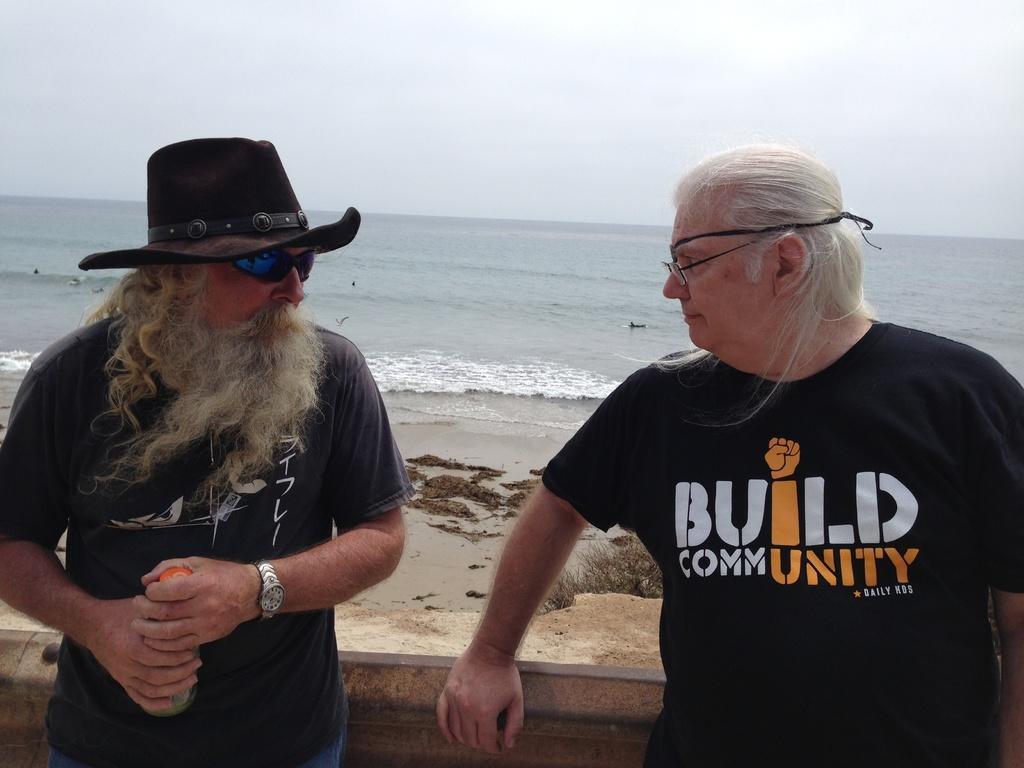Can you describe this image briefly? This is a beach. Here I can see two persons wearing t-shirts, standing and looking at each other. The person who is on the left side is holding an object in the hands and wearing a hat on the head. At the back of these people there is a wall. In the background there is an ocean. At the top of the image I can see the sky. 